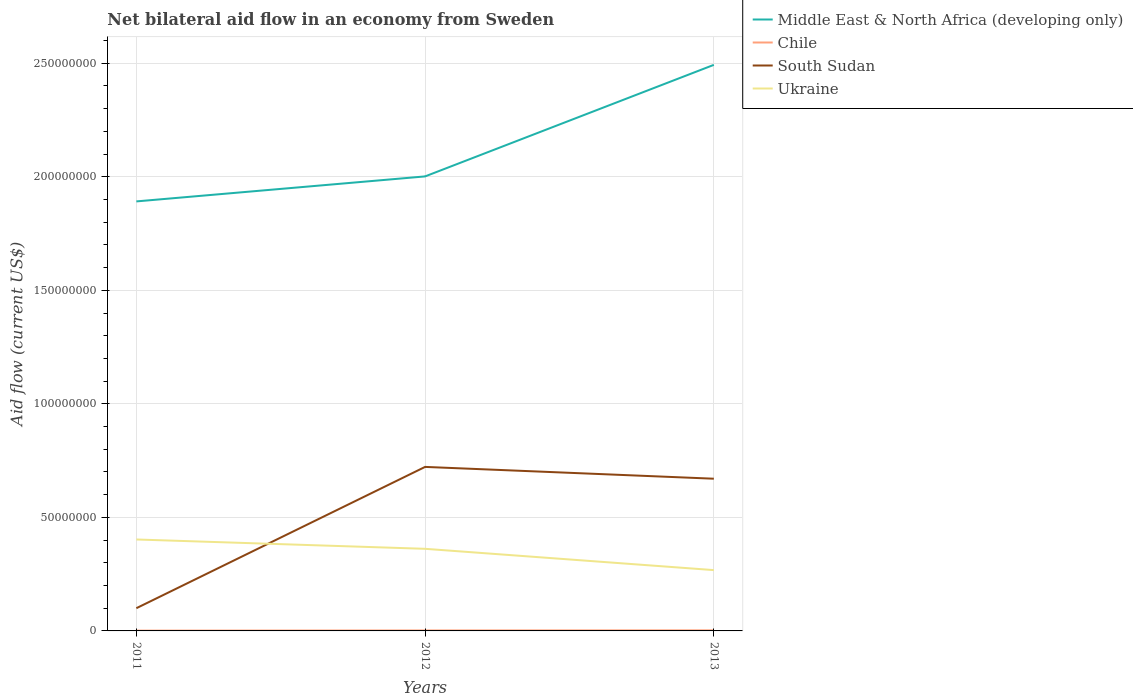Across all years, what is the maximum net bilateral aid flow in South Sudan?
Give a very brief answer. 1.00e+07. What is the total net bilateral aid flow in Ukraine in the graph?
Make the answer very short. 4.11e+06. What is the difference between the highest and the lowest net bilateral aid flow in South Sudan?
Provide a succinct answer. 2. How many lines are there?
Provide a short and direct response. 4. How many years are there in the graph?
Provide a succinct answer. 3. Does the graph contain grids?
Provide a succinct answer. Yes. Where does the legend appear in the graph?
Your answer should be compact. Top right. How many legend labels are there?
Keep it short and to the point. 4. What is the title of the graph?
Give a very brief answer. Net bilateral aid flow in an economy from Sweden. Does "Tunisia" appear as one of the legend labels in the graph?
Make the answer very short. No. What is the Aid flow (current US$) of Middle East & North Africa (developing only) in 2011?
Offer a terse response. 1.89e+08. What is the Aid flow (current US$) in Chile in 2011?
Ensure brevity in your answer.  1.40e+05. What is the Aid flow (current US$) of South Sudan in 2011?
Ensure brevity in your answer.  1.00e+07. What is the Aid flow (current US$) of Ukraine in 2011?
Offer a very short reply. 4.03e+07. What is the Aid flow (current US$) of Middle East & North Africa (developing only) in 2012?
Make the answer very short. 2.00e+08. What is the Aid flow (current US$) of Chile in 2012?
Make the answer very short. 2.10e+05. What is the Aid flow (current US$) of South Sudan in 2012?
Keep it short and to the point. 7.22e+07. What is the Aid flow (current US$) of Ukraine in 2012?
Your answer should be compact. 3.62e+07. What is the Aid flow (current US$) in Middle East & North Africa (developing only) in 2013?
Provide a short and direct response. 2.49e+08. What is the Aid flow (current US$) in Chile in 2013?
Keep it short and to the point. 2.60e+05. What is the Aid flow (current US$) of South Sudan in 2013?
Provide a short and direct response. 6.70e+07. What is the Aid flow (current US$) of Ukraine in 2013?
Ensure brevity in your answer.  2.68e+07. Across all years, what is the maximum Aid flow (current US$) of Middle East & North Africa (developing only)?
Your answer should be very brief. 2.49e+08. Across all years, what is the maximum Aid flow (current US$) in South Sudan?
Your response must be concise. 7.22e+07. Across all years, what is the maximum Aid flow (current US$) of Ukraine?
Ensure brevity in your answer.  4.03e+07. Across all years, what is the minimum Aid flow (current US$) in Middle East & North Africa (developing only)?
Keep it short and to the point. 1.89e+08. Across all years, what is the minimum Aid flow (current US$) of Chile?
Provide a succinct answer. 1.40e+05. Across all years, what is the minimum Aid flow (current US$) of South Sudan?
Your answer should be very brief. 1.00e+07. Across all years, what is the minimum Aid flow (current US$) in Ukraine?
Make the answer very short. 2.68e+07. What is the total Aid flow (current US$) of Middle East & North Africa (developing only) in the graph?
Your response must be concise. 6.39e+08. What is the total Aid flow (current US$) of South Sudan in the graph?
Your response must be concise. 1.49e+08. What is the total Aid flow (current US$) of Ukraine in the graph?
Make the answer very short. 1.03e+08. What is the difference between the Aid flow (current US$) in Middle East & North Africa (developing only) in 2011 and that in 2012?
Offer a very short reply. -1.10e+07. What is the difference between the Aid flow (current US$) of Chile in 2011 and that in 2012?
Your answer should be very brief. -7.00e+04. What is the difference between the Aid flow (current US$) of South Sudan in 2011 and that in 2012?
Give a very brief answer. -6.22e+07. What is the difference between the Aid flow (current US$) in Ukraine in 2011 and that in 2012?
Make the answer very short. 4.11e+06. What is the difference between the Aid flow (current US$) of Middle East & North Africa (developing only) in 2011 and that in 2013?
Your answer should be compact. -6.01e+07. What is the difference between the Aid flow (current US$) of South Sudan in 2011 and that in 2013?
Make the answer very short. -5.70e+07. What is the difference between the Aid flow (current US$) of Ukraine in 2011 and that in 2013?
Make the answer very short. 1.35e+07. What is the difference between the Aid flow (current US$) of Middle East & North Africa (developing only) in 2012 and that in 2013?
Provide a short and direct response. -4.91e+07. What is the difference between the Aid flow (current US$) of South Sudan in 2012 and that in 2013?
Provide a succinct answer. 5.20e+06. What is the difference between the Aid flow (current US$) in Ukraine in 2012 and that in 2013?
Provide a succinct answer. 9.38e+06. What is the difference between the Aid flow (current US$) in Middle East & North Africa (developing only) in 2011 and the Aid flow (current US$) in Chile in 2012?
Offer a very short reply. 1.89e+08. What is the difference between the Aid flow (current US$) in Middle East & North Africa (developing only) in 2011 and the Aid flow (current US$) in South Sudan in 2012?
Your response must be concise. 1.17e+08. What is the difference between the Aid flow (current US$) in Middle East & North Africa (developing only) in 2011 and the Aid flow (current US$) in Ukraine in 2012?
Make the answer very short. 1.53e+08. What is the difference between the Aid flow (current US$) of Chile in 2011 and the Aid flow (current US$) of South Sudan in 2012?
Ensure brevity in your answer.  -7.21e+07. What is the difference between the Aid flow (current US$) in Chile in 2011 and the Aid flow (current US$) in Ukraine in 2012?
Give a very brief answer. -3.60e+07. What is the difference between the Aid flow (current US$) of South Sudan in 2011 and the Aid flow (current US$) of Ukraine in 2012?
Offer a terse response. -2.62e+07. What is the difference between the Aid flow (current US$) in Middle East & North Africa (developing only) in 2011 and the Aid flow (current US$) in Chile in 2013?
Provide a succinct answer. 1.89e+08. What is the difference between the Aid flow (current US$) of Middle East & North Africa (developing only) in 2011 and the Aid flow (current US$) of South Sudan in 2013?
Keep it short and to the point. 1.22e+08. What is the difference between the Aid flow (current US$) in Middle East & North Africa (developing only) in 2011 and the Aid flow (current US$) in Ukraine in 2013?
Keep it short and to the point. 1.62e+08. What is the difference between the Aid flow (current US$) of Chile in 2011 and the Aid flow (current US$) of South Sudan in 2013?
Give a very brief answer. -6.69e+07. What is the difference between the Aid flow (current US$) in Chile in 2011 and the Aid flow (current US$) in Ukraine in 2013?
Keep it short and to the point. -2.66e+07. What is the difference between the Aid flow (current US$) of South Sudan in 2011 and the Aid flow (current US$) of Ukraine in 2013?
Make the answer very short. -1.68e+07. What is the difference between the Aid flow (current US$) in Middle East & North Africa (developing only) in 2012 and the Aid flow (current US$) in Chile in 2013?
Give a very brief answer. 2.00e+08. What is the difference between the Aid flow (current US$) of Middle East & North Africa (developing only) in 2012 and the Aid flow (current US$) of South Sudan in 2013?
Your answer should be compact. 1.33e+08. What is the difference between the Aid flow (current US$) of Middle East & North Africa (developing only) in 2012 and the Aid flow (current US$) of Ukraine in 2013?
Your answer should be very brief. 1.73e+08. What is the difference between the Aid flow (current US$) in Chile in 2012 and the Aid flow (current US$) in South Sudan in 2013?
Your answer should be very brief. -6.68e+07. What is the difference between the Aid flow (current US$) in Chile in 2012 and the Aid flow (current US$) in Ukraine in 2013?
Keep it short and to the point. -2.66e+07. What is the difference between the Aid flow (current US$) in South Sudan in 2012 and the Aid flow (current US$) in Ukraine in 2013?
Provide a succinct answer. 4.54e+07. What is the average Aid flow (current US$) of Middle East & North Africa (developing only) per year?
Offer a very short reply. 2.13e+08. What is the average Aid flow (current US$) of Chile per year?
Offer a terse response. 2.03e+05. What is the average Aid flow (current US$) of South Sudan per year?
Ensure brevity in your answer.  4.98e+07. What is the average Aid flow (current US$) of Ukraine per year?
Provide a succinct answer. 3.44e+07. In the year 2011, what is the difference between the Aid flow (current US$) in Middle East & North Africa (developing only) and Aid flow (current US$) in Chile?
Provide a succinct answer. 1.89e+08. In the year 2011, what is the difference between the Aid flow (current US$) in Middle East & North Africa (developing only) and Aid flow (current US$) in South Sudan?
Offer a terse response. 1.79e+08. In the year 2011, what is the difference between the Aid flow (current US$) in Middle East & North Africa (developing only) and Aid flow (current US$) in Ukraine?
Your response must be concise. 1.49e+08. In the year 2011, what is the difference between the Aid flow (current US$) of Chile and Aid flow (current US$) of South Sudan?
Your answer should be very brief. -9.87e+06. In the year 2011, what is the difference between the Aid flow (current US$) of Chile and Aid flow (current US$) of Ukraine?
Offer a very short reply. -4.01e+07. In the year 2011, what is the difference between the Aid flow (current US$) in South Sudan and Aid flow (current US$) in Ukraine?
Offer a very short reply. -3.03e+07. In the year 2012, what is the difference between the Aid flow (current US$) of Middle East & North Africa (developing only) and Aid flow (current US$) of Chile?
Your answer should be very brief. 2.00e+08. In the year 2012, what is the difference between the Aid flow (current US$) of Middle East & North Africa (developing only) and Aid flow (current US$) of South Sudan?
Keep it short and to the point. 1.28e+08. In the year 2012, what is the difference between the Aid flow (current US$) in Middle East & North Africa (developing only) and Aid flow (current US$) in Ukraine?
Provide a short and direct response. 1.64e+08. In the year 2012, what is the difference between the Aid flow (current US$) of Chile and Aid flow (current US$) of South Sudan?
Make the answer very short. -7.20e+07. In the year 2012, what is the difference between the Aid flow (current US$) in Chile and Aid flow (current US$) in Ukraine?
Your response must be concise. -3.60e+07. In the year 2012, what is the difference between the Aid flow (current US$) of South Sudan and Aid flow (current US$) of Ukraine?
Your answer should be very brief. 3.61e+07. In the year 2013, what is the difference between the Aid flow (current US$) in Middle East & North Africa (developing only) and Aid flow (current US$) in Chile?
Provide a succinct answer. 2.49e+08. In the year 2013, what is the difference between the Aid flow (current US$) in Middle East & North Africa (developing only) and Aid flow (current US$) in South Sudan?
Ensure brevity in your answer.  1.82e+08. In the year 2013, what is the difference between the Aid flow (current US$) of Middle East & North Africa (developing only) and Aid flow (current US$) of Ukraine?
Your answer should be very brief. 2.22e+08. In the year 2013, what is the difference between the Aid flow (current US$) in Chile and Aid flow (current US$) in South Sudan?
Your answer should be compact. -6.68e+07. In the year 2013, what is the difference between the Aid flow (current US$) of Chile and Aid flow (current US$) of Ukraine?
Give a very brief answer. -2.65e+07. In the year 2013, what is the difference between the Aid flow (current US$) in South Sudan and Aid flow (current US$) in Ukraine?
Ensure brevity in your answer.  4.02e+07. What is the ratio of the Aid flow (current US$) in Middle East & North Africa (developing only) in 2011 to that in 2012?
Your answer should be compact. 0.94. What is the ratio of the Aid flow (current US$) in South Sudan in 2011 to that in 2012?
Offer a terse response. 0.14. What is the ratio of the Aid flow (current US$) in Ukraine in 2011 to that in 2012?
Your response must be concise. 1.11. What is the ratio of the Aid flow (current US$) in Middle East & North Africa (developing only) in 2011 to that in 2013?
Ensure brevity in your answer.  0.76. What is the ratio of the Aid flow (current US$) in Chile in 2011 to that in 2013?
Your answer should be very brief. 0.54. What is the ratio of the Aid flow (current US$) of South Sudan in 2011 to that in 2013?
Ensure brevity in your answer.  0.15. What is the ratio of the Aid flow (current US$) of Ukraine in 2011 to that in 2013?
Provide a short and direct response. 1.5. What is the ratio of the Aid flow (current US$) of Middle East & North Africa (developing only) in 2012 to that in 2013?
Your answer should be compact. 0.8. What is the ratio of the Aid flow (current US$) in Chile in 2012 to that in 2013?
Your answer should be very brief. 0.81. What is the ratio of the Aid flow (current US$) of South Sudan in 2012 to that in 2013?
Your answer should be very brief. 1.08. What is the ratio of the Aid flow (current US$) in Ukraine in 2012 to that in 2013?
Provide a succinct answer. 1.35. What is the difference between the highest and the second highest Aid flow (current US$) in Middle East & North Africa (developing only)?
Ensure brevity in your answer.  4.91e+07. What is the difference between the highest and the second highest Aid flow (current US$) in South Sudan?
Your answer should be compact. 5.20e+06. What is the difference between the highest and the second highest Aid flow (current US$) in Ukraine?
Keep it short and to the point. 4.11e+06. What is the difference between the highest and the lowest Aid flow (current US$) of Middle East & North Africa (developing only)?
Offer a terse response. 6.01e+07. What is the difference between the highest and the lowest Aid flow (current US$) in South Sudan?
Keep it short and to the point. 6.22e+07. What is the difference between the highest and the lowest Aid flow (current US$) in Ukraine?
Provide a short and direct response. 1.35e+07. 